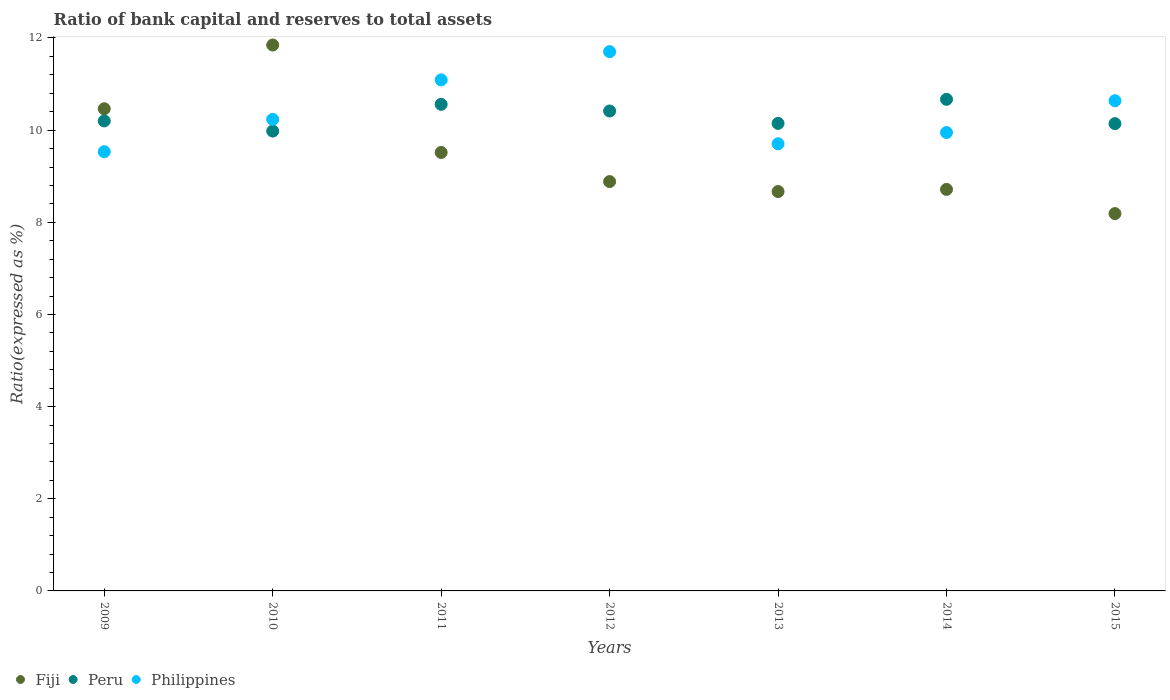Is the number of dotlines equal to the number of legend labels?
Your answer should be compact. Yes. What is the ratio of bank capital and reserves to total assets in Peru in 2009?
Your answer should be very brief. 10.2. Across all years, what is the maximum ratio of bank capital and reserves to total assets in Fiji?
Provide a short and direct response. 11.85. Across all years, what is the minimum ratio of bank capital and reserves to total assets in Fiji?
Keep it short and to the point. 8.19. In which year was the ratio of bank capital and reserves to total assets in Fiji minimum?
Offer a very short reply. 2015. What is the total ratio of bank capital and reserves to total assets in Philippines in the graph?
Your answer should be very brief. 72.85. What is the difference between the ratio of bank capital and reserves to total assets in Peru in 2012 and that in 2015?
Offer a terse response. 0.27. What is the difference between the ratio of bank capital and reserves to total assets in Peru in 2010 and the ratio of bank capital and reserves to total assets in Fiji in 2012?
Provide a succinct answer. 1.1. What is the average ratio of bank capital and reserves to total assets in Philippines per year?
Your answer should be very brief. 10.41. In the year 2013, what is the difference between the ratio of bank capital and reserves to total assets in Peru and ratio of bank capital and reserves to total assets in Fiji?
Make the answer very short. 1.48. In how many years, is the ratio of bank capital and reserves to total assets in Fiji greater than 3.6 %?
Keep it short and to the point. 7. What is the ratio of the ratio of bank capital and reserves to total assets in Philippines in 2012 to that in 2014?
Ensure brevity in your answer.  1.18. Is the ratio of bank capital and reserves to total assets in Peru in 2012 less than that in 2014?
Ensure brevity in your answer.  Yes. What is the difference between the highest and the second highest ratio of bank capital and reserves to total assets in Peru?
Your answer should be very brief. 0.11. What is the difference between the highest and the lowest ratio of bank capital and reserves to total assets in Fiji?
Make the answer very short. 3.66. In how many years, is the ratio of bank capital and reserves to total assets in Fiji greater than the average ratio of bank capital and reserves to total assets in Fiji taken over all years?
Give a very brief answer. 3. How many dotlines are there?
Make the answer very short. 3. How many years are there in the graph?
Your answer should be compact. 7. Does the graph contain grids?
Offer a very short reply. No. Where does the legend appear in the graph?
Offer a terse response. Bottom left. How many legend labels are there?
Make the answer very short. 3. How are the legend labels stacked?
Your response must be concise. Horizontal. What is the title of the graph?
Offer a very short reply. Ratio of bank capital and reserves to total assets. What is the label or title of the Y-axis?
Make the answer very short. Ratio(expressed as %). What is the Ratio(expressed as %) in Fiji in 2009?
Offer a very short reply. 10.46. What is the Ratio(expressed as %) in Peru in 2009?
Offer a terse response. 10.2. What is the Ratio(expressed as %) in Philippines in 2009?
Keep it short and to the point. 9.53. What is the Ratio(expressed as %) of Fiji in 2010?
Provide a succinct answer. 11.85. What is the Ratio(expressed as %) in Peru in 2010?
Your answer should be compact. 9.98. What is the Ratio(expressed as %) of Philippines in 2010?
Provide a succinct answer. 10.23. What is the Ratio(expressed as %) of Fiji in 2011?
Provide a short and direct response. 9.52. What is the Ratio(expressed as %) of Peru in 2011?
Keep it short and to the point. 10.56. What is the Ratio(expressed as %) in Philippines in 2011?
Keep it short and to the point. 11.09. What is the Ratio(expressed as %) of Fiji in 2012?
Offer a very short reply. 8.88. What is the Ratio(expressed as %) of Peru in 2012?
Your answer should be compact. 10.42. What is the Ratio(expressed as %) of Philippines in 2012?
Provide a short and direct response. 11.7. What is the Ratio(expressed as %) of Fiji in 2013?
Your answer should be very brief. 8.67. What is the Ratio(expressed as %) in Peru in 2013?
Provide a succinct answer. 10.15. What is the Ratio(expressed as %) in Philippines in 2013?
Provide a succinct answer. 9.7. What is the Ratio(expressed as %) of Fiji in 2014?
Offer a very short reply. 8.71. What is the Ratio(expressed as %) of Peru in 2014?
Make the answer very short. 10.67. What is the Ratio(expressed as %) in Philippines in 2014?
Your answer should be very brief. 9.95. What is the Ratio(expressed as %) in Fiji in 2015?
Your answer should be very brief. 8.19. What is the Ratio(expressed as %) of Peru in 2015?
Make the answer very short. 10.14. What is the Ratio(expressed as %) in Philippines in 2015?
Offer a terse response. 10.64. Across all years, what is the maximum Ratio(expressed as %) in Fiji?
Ensure brevity in your answer.  11.85. Across all years, what is the maximum Ratio(expressed as %) in Peru?
Offer a very short reply. 10.67. Across all years, what is the maximum Ratio(expressed as %) of Philippines?
Offer a very short reply. 11.7. Across all years, what is the minimum Ratio(expressed as %) in Fiji?
Give a very brief answer. 8.19. Across all years, what is the minimum Ratio(expressed as %) of Peru?
Provide a succinct answer. 9.98. Across all years, what is the minimum Ratio(expressed as %) of Philippines?
Your answer should be compact. 9.53. What is the total Ratio(expressed as %) in Fiji in the graph?
Your answer should be compact. 66.28. What is the total Ratio(expressed as %) in Peru in the graph?
Your response must be concise. 72.11. What is the total Ratio(expressed as %) of Philippines in the graph?
Offer a very short reply. 72.85. What is the difference between the Ratio(expressed as %) of Fiji in 2009 and that in 2010?
Provide a short and direct response. -1.38. What is the difference between the Ratio(expressed as %) of Peru in 2009 and that in 2010?
Make the answer very short. 0.22. What is the difference between the Ratio(expressed as %) in Philippines in 2009 and that in 2010?
Provide a succinct answer. -0.7. What is the difference between the Ratio(expressed as %) of Fiji in 2009 and that in 2011?
Provide a short and direct response. 0.95. What is the difference between the Ratio(expressed as %) in Peru in 2009 and that in 2011?
Your answer should be very brief. -0.36. What is the difference between the Ratio(expressed as %) in Philippines in 2009 and that in 2011?
Offer a very short reply. -1.56. What is the difference between the Ratio(expressed as %) of Fiji in 2009 and that in 2012?
Offer a terse response. 1.58. What is the difference between the Ratio(expressed as %) in Peru in 2009 and that in 2012?
Provide a succinct answer. -0.22. What is the difference between the Ratio(expressed as %) in Philippines in 2009 and that in 2012?
Offer a very short reply. -2.17. What is the difference between the Ratio(expressed as %) in Fiji in 2009 and that in 2013?
Make the answer very short. 1.8. What is the difference between the Ratio(expressed as %) of Peru in 2009 and that in 2013?
Offer a terse response. 0.05. What is the difference between the Ratio(expressed as %) in Philippines in 2009 and that in 2013?
Your answer should be compact. -0.17. What is the difference between the Ratio(expressed as %) in Fiji in 2009 and that in 2014?
Make the answer very short. 1.75. What is the difference between the Ratio(expressed as %) in Peru in 2009 and that in 2014?
Your response must be concise. -0.47. What is the difference between the Ratio(expressed as %) in Philippines in 2009 and that in 2014?
Offer a very short reply. -0.42. What is the difference between the Ratio(expressed as %) in Fiji in 2009 and that in 2015?
Offer a terse response. 2.28. What is the difference between the Ratio(expressed as %) of Peru in 2009 and that in 2015?
Provide a short and direct response. 0.06. What is the difference between the Ratio(expressed as %) of Philippines in 2009 and that in 2015?
Provide a succinct answer. -1.11. What is the difference between the Ratio(expressed as %) in Fiji in 2010 and that in 2011?
Offer a very short reply. 2.33. What is the difference between the Ratio(expressed as %) of Peru in 2010 and that in 2011?
Your answer should be compact. -0.58. What is the difference between the Ratio(expressed as %) in Philippines in 2010 and that in 2011?
Provide a short and direct response. -0.86. What is the difference between the Ratio(expressed as %) in Fiji in 2010 and that in 2012?
Give a very brief answer. 2.96. What is the difference between the Ratio(expressed as %) of Peru in 2010 and that in 2012?
Ensure brevity in your answer.  -0.44. What is the difference between the Ratio(expressed as %) of Philippines in 2010 and that in 2012?
Ensure brevity in your answer.  -1.47. What is the difference between the Ratio(expressed as %) of Fiji in 2010 and that in 2013?
Make the answer very short. 3.18. What is the difference between the Ratio(expressed as %) in Peru in 2010 and that in 2013?
Make the answer very short. -0.17. What is the difference between the Ratio(expressed as %) of Philippines in 2010 and that in 2013?
Keep it short and to the point. 0.53. What is the difference between the Ratio(expressed as %) of Fiji in 2010 and that in 2014?
Provide a short and direct response. 3.13. What is the difference between the Ratio(expressed as %) of Peru in 2010 and that in 2014?
Your response must be concise. -0.69. What is the difference between the Ratio(expressed as %) in Philippines in 2010 and that in 2014?
Provide a succinct answer. 0.29. What is the difference between the Ratio(expressed as %) in Fiji in 2010 and that in 2015?
Keep it short and to the point. 3.66. What is the difference between the Ratio(expressed as %) in Peru in 2010 and that in 2015?
Your answer should be compact. -0.16. What is the difference between the Ratio(expressed as %) in Philippines in 2010 and that in 2015?
Your answer should be very brief. -0.4. What is the difference between the Ratio(expressed as %) of Fiji in 2011 and that in 2012?
Offer a terse response. 0.63. What is the difference between the Ratio(expressed as %) of Peru in 2011 and that in 2012?
Provide a short and direct response. 0.14. What is the difference between the Ratio(expressed as %) in Philippines in 2011 and that in 2012?
Provide a succinct answer. -0.61. What is the difference between the Ratio(expressed as %) in Fiji in 2011 and that in 2013?
Provide a succinct answer. 0.85. What is the difference between the Ratio(expressed as %) of Peru in 2011 and that in 2013?
Provide a short and direct response. 0.41. What is the difference between the Ratio(expressed as %) of Philippines in 2011 and that in 2013?
Your answer should be compact. 1.39. What is the difference between the Ratio(expressed as %) of Fiji in 2011 and that in 2014?
Keep it short and to the point. 0.8. What is the difference between the Ratio(expressed as %) in Peru in 2011 and that in 2014?
Provide a short and direct response. -0.11. What is the difference between the Ratio(expressed as %) of Philippines in 2011 and that in 2014?
Provide a short and direct response. 1.14. What is the difference between the Ratio(expressed as %) of Fiji in 2011 and that in 2015?
Offer a very short reply. 1.33. What is the difference between the Ratio(expressed as %) of Peru in 2011 and that in 2015?
Give a very brief answer. 0.42. What is the difference between the Ratio(expressed as %) in Philippines in 2011 and that in 2015?
Provide a succinct answer. 0.45. What is the difference between the Ratio(expressed as %) of Fiji in 2012 and that in 2013?
Make the answer very short. 0.22. What is the difference between the Ratio(expressed as %) of Peru in 2012 and that in 2013?
Ensure brevity in your answer.  0.27. What is the difference between the Ratio(expressed as %) in Philippines in 2012 and that in 2013?
Provide a succinct answer. 2. What is the difference between the Ratio(expressed as %) of Fiji in 2012 and that in 2014?
Make the answer very short. 0.17. What is the difference between the Ratio(expressed as %) of Peru in 2012 and that in 2014?
Ensure brevity in your answer.  -0.25. What is the difference between the Ratio(expressed as %) of Philippines in 2012 and that in 2014?
Offer a terse response. 1.75. What is the difference between the Ratio(expressed as %) in Fiji in 2012 and that in 2015?
Make the answer very short. 0.7. What is the difference between the Ratio(expressed as %) in Peru in 2012 and that in 2015?
Give a very brief answer. 0.27. What is the difference between the Ratio(expressed as %) in Philippines in 2012 and that in 2015?
Offer a terse response. 1.06. What is the difference between the Ratio(expressed as %) in Fiji in 2013 and that in 2014?
Make the answer very short. -0.05. What is the difference between the Ratio(expressed as %) in Peru in 2013 and that in 2014?
Make the answer very short. -0.52. What is the difference between the Ratio(expressed as %) in Philippines in 2013 and that in 2014?
Your answer should be compact. -0.24. What is the difference between the Ratio(expressed as %) in Fiji in 2013 and that in 2015?
Make the answer very short. 0.48. What is the difference between the Ratio(expressed as %) in Peru in 2013 and that in 2015?
Make the answer very short. 0.01. What is the difference between the Ratio(expressed as %) of Philippines in 2013 and that in 2015?
Provide a succinct answer. -0.93. What is the difference between the Ratio(expressed as %) of Fiji in 2014 and that in 2015?
Make the answer very short. 0.53. What is the difference between the Ratio(expressed as %) of Peru in 2014 and that in 2015?
Provide a short and direct response. 0.53. What is the difference between the Ratio(expressed as %) in Philippines in 2014 and that in 2015?
Give a very brief answer. -0.69. What is the difference between the Ratio(expressed as %) of Fiji in 2009 and the Ratio(expressed as %) of Peru in 2010?
Provide a succinct answer. 0.48. What is the difference between the Ratio(expressed as %) in Fiji in 2009 and the Ratio(expressed as %) in Philippines in 2010?
Offer a terse response. 0.23. What is the difference between the Ratio(expressed as %) of Peru in 2009 and the Ratio(expressed as %) of Philippines in 2010?
Ensure brevity in your answer.  -0.03. What is the difference between the Ratio(expressed as %) in Fiji in 2009 and the Ratio(expressed as %) in Peru in 2011?
Provide a succinct answer. -0.1. What is the difference between the Ratio(expressed as %) of Fiji in 2009 and the Ratio(expressed as %) of Philippines in 2011?
Ensure brevity in your answer.  -0.63. What is the difference between the Ratio(expressed as %) in Peru in 2009 and the Ratio(expressed as %) in Philippines in 2011?
Offer a terse response. -0.89. What is the difference between the Ratio(expressed as %) of Fiji in 2009 and the Ratio(expressed as %) of Peru in 2012?
Make the answer very short. 0.05. What is the difference between the Ratio(expressed as %) of Fiji in 2009 and the Ratio(expressed as %) of Philippines in 2012?
Provide a short and direct response. -1.24. What is the difference between the Ratio(expressed as %) of Peru in 2009 and the Ratio(expressed as %) of Philippines in 2012?
Provide a succinct answer. -1.5. What is the difference between the Ratio(expressed as %) of Fiji in 2009 and the Ratio(expressed as %) of Peru in 2013?
Offer a very short reply. 0.32. What is the difference between the Ratio(expressed as %) of Fiji in 2009 and the Ratio(expressed as %) of Philippines in 2013?
Make the answer very short. 0.76. What is the difference between the Ratio(expressed as %) in Peru in 2009 and the Ratio(expressed as %) in Philippines in 2013?
Your answer should be very brief. 0.5. What is the difference between the Ratio(expressed as %) of Fiji in 2009 and the Ratio(expressed as %) of Peru in 2014?
Make the answer very short. -0.2. What is the difference between the Ratio(expressed as %) of Fiji in 2009 and the Ratio(expressed as %) of Philippines in 2014?
Provide a short and direct response. 0.52. What is the difference between the Ratio(expressed as %) in Peru in 2009 and the Ratio(expressed as %) in Philippines in 2014?
Keep it short and to the point. 0.25. What is the difference between the Ratio(expressed as %) in Fiji in 2009 and the Ratio(expressed as %) in Peru in 2015?
Give a very brief answer. 0.32. What is the difference between the Ratio(expressed as %) in Fiji in 2009 and the Ratio(expressed as %) in Philippines in 2015?
Offer a terse response. -0.17. What is the difference between the Ratio(expressed as %) in Peru in 2009 and the Ratio(expressed as %) in Philippines in 2015?
Provide a short and direct response. -0.44. What is the difference between the Ratio(expressed as %) of Fiji in 2010 and the Ratio(expressed as %) of Peru in 2011?
Provide a short and direct response. 1.29. What is the difference between the Ratio(expressed as %) of Fiji in 2010 and the Ratio(expressed as %) of Philippines in 2011?
Keep it short and to the point. 0.76. What is the difference between the Ratio(expressed as %) of Peru in 2010 and the Ratio(expressed as %) of Philippines in 2011?
Offer a terse response. -1.11. What is the difference between the Ratio(expressed as %) in Fiji in 2010 and the Ratio(expressed as %) in Peru in 2012?
Give a very brief answer. 1.43. What is the difference between the Ratio(expressed as %) of Fiji in 2010 and the Ratio(expressed as %) of Philippines in 2012?
Provide a short and direct response. 0.14. What is the difference between the Ratio(expressed as %) in Peru in 2010 and the Ratio(expressed as %) in Philippines in 2012?
Offer a terse response. -1.72. What is the difference between the Ratio(expressed as %) of Fiji in 2010 and the Ratio(expressed as %) of Peru in 2013?
Provide a succinct answer. 1.7. What is the difference between the Ratio(expressed as %) in Fiji in 2010 and the Ratio(expressed as %) in Philippines in 2013?
Provide a short and direct response. 2.14. What is the difference between the Ratio(expressed as %) of Peru in 2010 and the Ratio(expressed as %) of Philippines in 2013?
Keep it short and to the point. 0.28. What is the difference between the Ratio(expressed as %) of Fiji in 2010 and the Ratio(expressed as %) of Peru in 2014?
Your response must be concise. 1.18. What is the difference between the Ratio(expressed as %) of Fiji in 2010 and the Ratio(expressed as %) of Philippines in 2014?
Make the answer very short. 1.9. What is the difference between the Ratio(expressed as %) in Peru in 2010 and the Ratio(expressed as %) in Philippines in 2014?
Make the answer very short. 0.03. What is the difference between the Ratio(expressed as %) of Fiji in 2010 and the Ratio(expressed as %) of Peru in 2015?
Offer a terse response. 1.71. What is the difference between the Ratio(expressed as %) in Fiji in 2010 and the Ratio(expressed as %) in Philippines in 2015?
Your answer should be compact. 1.21. What is the difference between the Ratio(expressed as %) of Peru in 2010 and the Ratio(expressed as %) of Philippines in 2015?
Provide a succinct answer. -0.66. What is the difference between the Ratio(expressed as %) of Fiji in 2011 and the Ratio(expressed as %) of Peru in 2012?
Offer a very short reply. -0.9. What is the difference between the Ratio(expressed as %) in Fiji in 2011 and the Ratio(expressed as %) in Philippines in 2012?
Provide a succinct answer. -2.19. What is the difference between the Ratio(expressed as %) in Peru in 2011 and the Ratio(expressed as %) in Philippines in 2012?
Your response must be concise. -1.14. What is the difference between the Ratio(expressed as %) in Fiji in 2011 and the Ratio(expressed as %) in Peru in 2013?
Ensure brevity in your answer.  -0.63. What is the difference between the Ratio(expressed as %) in Fiji in 2011 and the Ratio(expressed as %) in Philippines in 2013?
Your response must be concise. -0.19. What is the difference between the Ratio(expressed as %) in Peru in 2011 and the Ratio(expressed as %) in Philippines in 2013?
Offer a terse response. 0.86. What is the difference between the Ratio(expressed as %) of Fiji in 2011 and the Ratio(expressed as %) of Peru in 2014?
Provide a succinct answer. -1.15. What is the difference between the Ratio(expressed as %) in Fiji in 2011 and the Ratio(expressed as %) in Philippines in 2014?
Ensure brevity in your answer.  -0.43. What is the difference between the Ratio(expressed as %) in Peru in 2011 and the Ratio(expressed as %) in Philippines in 2014?
Your answer should be compact. 0.61. What is the difference between the Ratio(expressed as %) in Fiji in 2011 and the Ratio(expressed as %) in Peru in 2015?
Give a very brief answer. -0.63. What is the difference between the Ratio(expressed as %) in Fiji in 2011 and the Ratio(expressed as %) in Philippines in 2015?
Your response must be concise. -1.12. What is the difference between the Ratio(expressed as %) of Peru in 2011 and the Ratio(expressed as %) of Philippines in 2015?
Your answer should be compact. -0.08. What is the difference between the Ratio(expressed as %) of Fiji in 2012 and the Ratio(expressed as %) of Peru in 2013?
Your response must be concise. -1.26. What is the difference between the Ratio(expressed as %) of Fiji in 2012 and the Ratio(expressed as %) of Philippines in 2013?
Ensure brevity in your answer.  -0.82. What is the difference between the Ratio(expressed as %) in Peru in 2012 and the Ratio(expressed as %) in Philippines in 2013?
Your answer should be very brief. 0.71. What is the difference between the Ratio(expressed as %) in Fiji in 2012 and the Ratio(expressed as %) in Peru in 2014?
Ensure brevity in your answer.  -1.78. What is the difference between the Ratio(expressed as %) of Fiji in 2012 and the Ratio(expressed as %) of Philippines in 2014?
Keep it short and to the point. -1.06. What is the difference between the Ratio(expressed as %) of Peru in 2012 and the Ratio(expressed as %) of Philippines in 2014?
Your response must be concise. 0.47. What is the difference between the Ratio(expressed as %) of Fiji in 2012 and the Ratio(expressed as %) of Peru in 2015?
Keep it short and to the point. -1.26. What is the difference between the Ratio(expressed as %) of Fiji in 2012 and the Ratio(expressed as %) of Philippines in 2015?
Make the answer very short. -1.75. What is the difference between the Ratio(expressed as %) in Peru in 2012 and the Ratio(expressed as %) in Philippines in 2015?
Provide a succinct answer. -0.22. What is the difference between the Ratio(expressed as %) in Fiji in 2013 and the Ratio(expressed as %) in Peru in 2014?
Offer a terse response. -2. What is the difference between the Ratio(expressed as %) of Fiji in 2013 and the Ratio(expressed as %) of Philippines in 2014?
Provide a short and direct response. -1.28. What is the difference between the Ratio(expressed as %) of Peru in 2013 and the Ratio(expressed as %) of Philippines in 2014?
Your answer should be very brief. 0.2. What is the difference between the Ratio(expressed as %) of Fiji in 2013 and the Ratio(expressed as %) of Peru in 2015?
Your response must be concise. -1.47. What is the difference between the Ratio(expressed as %) of Fiji in 2013 and the Ratio(expressed as %) of Philippines in 2015?
Make the answer very short. -1.97. What is the difference between the Ratio(expressed as %) of Peru in 2013 and the Ratio(expressed as %) of Philippines in 2015?
Provide a succinct answer. -0.49. What is the difference between the Ratio(expressed as %) of Fiji in 2014 and the Ratio(expressed as %) of Peru in 2015?
Your response must be concise. -1.43. What is the difference between the Ratio(expressed as %) in Fiji in 2014 and the Ratio(expressed as %) in Philippines in 2015?
Ensure brevity in your answer.  -1.92. What is the difference between the Ratio(expressed as %) in Peru in 2014 and the Ratio(expressed as %) in Philippines in 2015?
Make the answer very short. 0.03. What is the average Ratio(expressed as %) of Fiji per year?
Your answer should be compact. 9.47. What is the average Ratio(expressed as %) of Peru per year?
Provide a succinct answer. 10.3. What is the average Ratio(expressed as %) of Philippines per year?
Make the answer very short. 10.41. In the year 2009, what is the difference between the Ratio(expressed as %) in Fiji and Ratio(expressed as %) in Peru?
Ensure brevity in your answer.  0.26. In the year 2009, what is the difference between the Ratio(expressed as %) in Fiji and Ratio(expressed as %) in Philippines?
Offer a very short reply. 0.93. In the year 2009, what is the difference between the Ratio(expressed as %) in Peru and Ratio(expressed as %) in Philippines?
Provide a succinct answer. 0.67. In the year 2010, what is the difference between the Ratio(expressed as %) in Fiji and Ratio(expressed as %) in Peru?
Make the answer very short. 1.87. In the year 2010, what is the difference between the Ratio(expressed as %) in Fiji and Ratio(expressed as %) in Philippines?
Provide a short and direct response. 1.61. In the year 2010, what is the difference between the Ratio(expressed as %) of Peru and Ratio(expressed as %) of Philippines?
Keep it short and to the point. -0.25. In the year 2011, what is the difference between the Ratio(expressed as %) in Fiji and Ratio(expressed as %) in Peru?
Make the answer very short. -1.04. In the year 2011, what is the difference between the Ratio(expressed as %) in Fiji and Ratio(expressed as %) in Philippines?
Give a very brief answer. -1.57. In the year 2011, what is the difference between the Ratio(expressed as %) in Peru and Ratio(expressed as %) in Philippines?
Your answer should be compact. -0.53. In the year 2012, what is the difference between the Ratio(expressed as %) in Fiji and Ratio(expressed as %) in Peru?
Your answer should be compact. -1.53. In the year 2012, what is the difference between the Ratio(expressed as %) of Fiji and Ratio(expressed as %) of Philippines?
Your answer should be compact. -2.82. In the year 2012, what is the difference between the Ratio(expressed as %) of Peru and Ratio(expressed as %) of Philippines?
Offer a terse response. -1.29. In the year 2013, what is the difference between the Ratio(expressed as %) of Fiji and Ratio(expressed as %) of Peru?
Make the answer very short. -1.48. In the year 2013, what is the difference between the Ratio(expressed as %) in Fiji and Ratio(expressed as %) in Philippines?
Provide a short and direct response. -1.04. In the year 2013, what is the difference between the Ratio(expressed as %) in Peru and Ratio(expressed as %) in Philippines?
Offer a very short reply. 0.44. In the year 2014, what is the difference between the Ratio(expressed as %) in Fiji and Ratio(expressed as %) in Peru?
Your answer should be compact. -1.95. In the year 2014, what is the difference between the Ratio(expressed as %) in Fiji and Ratio(expressed as %) in Philippines?
Your answer should be compact. -1.23. In the year 2014, what is the difference between the Ratio(expressed as %) of Peru and Ratio(expressed as %) of Philippines?
Provide a succinct answer. 0.72. In the year 2015, what is the difference between the Ratio(expressed as %) in Fiji and Ratio(expressed as %) in Peru?
Ensure brevity in your answer.  -1.95. In the year 2015, what is the difference between the Ratio(expressed as %) of Fiji and Ratio(expressed as %) of Philippines?
Offer a very short reply. -2.45. In the year 2015, what is the difference between the Ratio(expressed as %) of Peru and Ratio(expressed as %) of Philippines?
Keep it short and to the point. -0.5. What is the ratio of the Ratio(expressed as %) in Fiji in 2009 to that in 2010?
Your answer should be compact. 0.88. What is the ratio of the Ratio(expressed as %) of Peru in 2009 to that in 2010?
Your answer should be compact. 1.02. What is the ratio of the Ratio(expressed as %) of Philippines in 2009 to that in 2010?
Offer a terse response. 0.93. What is the ratio of the Ratio(expressed as %) in Fiji in 2009 to that in 2011?
Keep it short and to the point. 1.1. What is the ratio of the Ratio(expressed as %) of Peru in 2009 to that in 2011?
Make the answer very short. 0.97. What is the ratio of the Ratio(expressed as %) in Philippines in 2009 to that in 2011?
Keep it short and to the point. 0.86. What is the ratio of the Ratio(expressed as %) of Fiji in 2009 to that in 2012?
Offer a very short reply. 1.18. What is the ratio of the Ratio(expressed as %) of Peru in 2009 to that in 2012?
Keep it short and to the point. 0.98. What is the ratio of the Ratio(expressed as %) in Philippines in 2009 to that in 2012?
Ensure brevity in your answer.  0.81. What is the ratio of the Ratio(expressed as %) of Fiji in 2009 to that in 2013?
Provide a succinct answer. 1.21. What is the ratio of the Ratio(expressed as %) of Peru in 2009 to that in 2013?
Your answer should be compact. 1.01. What is the ratio of the Ratio(expressed as %) of Philippines in 2009 to that in 2013?
Make the answer very short. 0.98. What is the ratio of the Ratio(expressed as %) of Fiji in 2009 to that in 2014?
Make the answer very short. 1.2. What is the ratio of the Ratio(expressed as %) of Peru in 2009 to that in 2014?
Make the answer very short. 0.96. What is the ratio of the Ratio(expressed as %) in Philippines in 2009 to that in 2014?
Your answer should be compact. 0.96. What is the ratio of the Ratio(expressed as %) in Fiji in 2009 to that in 2015?
Ensure brevity in your answer.  1.28. What is the ratio of the Ratio(expressed as %) of Peru in 2009 to that in 2015?
Ensure brevity in your answer.  1.01. What is the ratio of the Ratio(expressed as %) in Philippines in 2009 to that in 2015?
Your answer should be compact. 0.9. What is the ratio of the Ratio(expressed as %) of Fiji in 2010 to that in 2011?
Your answer should be compact. 1.25. What is the ratio of the Ratio(expressed as %) of Peru in 2010 to that in 2011?
Keep it short and to the point. 0.94. What is the ratio of the Ratio(expressed as %) in Philippines in 2010 to that in 2011?
Your response must be concise. 0.92. What is the ratio of the Ratio(expressed as %) of Fiji in 2010 to that in 2012?
Your answer should be compact. 1.33. What is the ratio of the Ratio(expressed as %) of Peru in 2010 to that in 2012?
Make the answer very short. 0.96. What is the ratio of the Ratio(expressed as %) of Philippines in 2010 to that in 2012?
Your response must be concise. 0.87. What is the ratio of the Ratio(expressed as %) of Fiji in 2010 to that in 2013?
Your answer should be very brief. 1.37. What is the ratio of the Ratio(expressed as %) in Peru in 2010 to that in 2013?
Your answer should be compact. 0.98. What is the ratio of the Ratio(expressed as %) in Philippines in 2010 to that in 2013?
Your response must be concise. 1.05. What is the ratio of the Ratio(expressed as %) of Fiji in 2010 to that in 2014?
Provide a succinct answer. 1.36. What is the ratio of the Ratio(expressed as %) in Peru in 2010 to that in 2014?
Provide a short and direct response. 0.94. What is the ratio of the Ratio(expressed as %) in Philippines in 2010 to that in 2014?
Make the answer very short. 1.03. What is the ratio of the Ratio(expressed as %) of Fiji in 2010 to that in 2015?
Offer a terse response. 1.45. What is the ratio of the Ratio(expressed as %) in Peru in 2010 to that in 2015?
Provide a succinct answer. 0.98. What is the ratio of the Ratio(expressed as %) in Fiji in 2011 to that in 2012?
Keep it short and to the point. 1.07. What is the ratio of the Ratio(expressed as %) in Peru in 2011 to that in 2012?
Offer a terse response. 1.01. What is the ratio of the Ratio(expressed as %) of Philippines in 2011 to that in 2012?
Your answer should be compact. 0.95. What is the ratio of the Ratio(expressed as %) of Fiji in 2011 to that in 2013?
Your answer should be very brief. 1.1. What is the ratio of the Ratio(expressed as %) in Peru in 2011 to that in 2013?
Your answer should be very brief. 1.04. What is the ratio of the Ratio(expressed as %) in Fiji in 2011 to that in 2014?
Provide a succinct answer. 1.09. What is the ratio of the Ratio(expressed as %) of Peru in 2011 to that in 2014?
Your answer should be very brief. 0.99. What is the ratio of the Ratio(expressed as %) in Philippines in 2011 to that in 2014?
Make the answer very short. 1.11. What is the ratio of the Ratio(expressed as %) in Fiji in 2011 to that in 2015?
Your answer should be very brief. 1.16. What is the ratio of the Ratio(expressed as %) in Peru in 2011 to that in 2015?
Your response must be concise. 1.04. What is the ratio of the Ratio(expressed as %) of Philippines in 2011 to that in 2015?
Provide a succinct answer. 1.04. What is the ratio of the Ratio(expressed as %) in Peru in 2012 to that in 2013?
Make the answer very short. 1.03. What is the ratio of the Ratio(expressed as %) of Philippines in 2012 to that in 2013?
Keep it short and to the point. 1.21. What is the ratio of the Ratio(expressed as %) in Fiji in 2012 to that in 2014?
Ensure brevity in your answer.  1.02. What is the ratio of the Ratio(expressed as %) of Peru in 2012 to that in 2014?
Offer a terse response. 0.98. What is the ratio of the Ratio(expressed as %) of Philippines in 2012 to that in 2014?
Your response must be concise. 1.18. What is the ratio of the Ratio(expressed as %) of Fiji in 2012 to that in 2015?
Offer a terse response. 1.08. What is the ratio of the Ratio(expressed as %) in Peru in 2012 to that in 2015?
Ensure brevity in your answer.  1.03. What is the ratio of the Ratio(expressed as %) in Philippines in 2012 to that in 2015?
Keep it short and to the point. 1.1. What is the ratio of the Ratio(expressed as %) in Peru in 2013 to that in 2014?
Offer a very short reply. 0.95. What is the ratio of the Ratio(expressed as %) in Philippines in 2013 to that in 2014?
Provide a short and direct response. 0.98. What is the ratio of the Ratio(expressed as %) in Fiji in 2013 to that in 2015?
Provide a succinct answer. 1.06. What is the ratio of the Ratio(expressed as %) of Peru in 2013 to that in 2015?
Give a very brief answer. 1. What is the ratio of the Ratio(expressed as %) of Philippines in 2013 to that in 2015?
Your response must be concise. 0.91. What is the ratio of the Ratio(expressed as %) of Fiji in 2014 to that in 2015?
Your response must be concise. 1.06. What is the ratio of the Ratio(expressed as %) of Peru in 2014 to that in 2015?
Your response must be concise. 1.05. What is the ratio of the Ratio(expressed as %) of Philippines in 2014 to that in 2015?
Your answer should be very brief. 0.94. What is the difference between the highest and the second highest Ratio(expressed as %) in Fiji?
Ensure brevity in your answer.  1.38. What is the difference between the highest and the second highest Ratio(expressed as %) in Peru?
Provide a short and direct response. 0.11. What is the difference between the highest and the second highest Ratio(expressed as %) in Philippines?
Provide a short and direct response. 0.61. What is the difference between the highest and the lowest Ratio(expressed as %) in Fiji?
Make the answer very short. 3.66. What is the difference between the highest and the lowest Ratio(expressed as %) of Peru?
Give a very brief answer. 0.69. What is the difference between the highest and the lowest Ratio(expressed as %) of Philippines?
Keep it short and to the point. 2.17. 